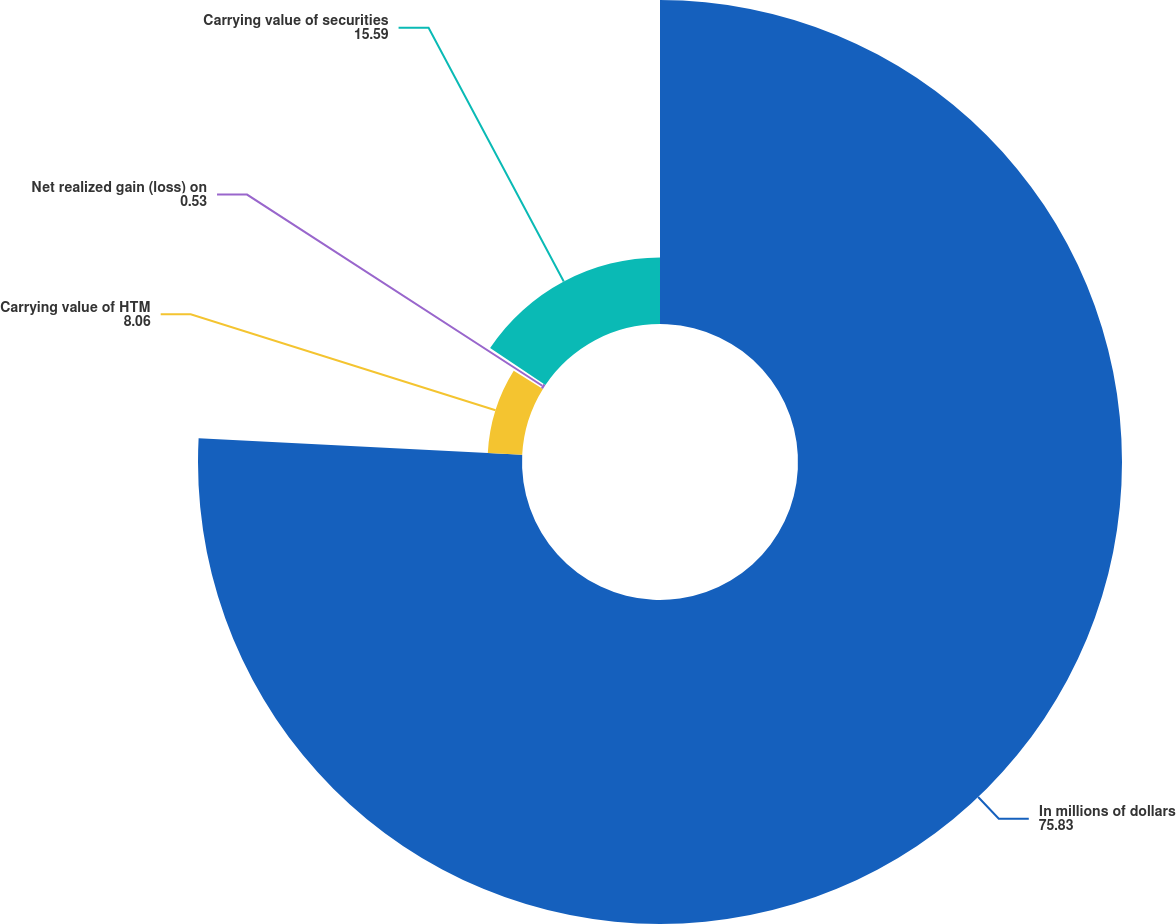<chart> <loc_0><loc_0><loc_500><loc_500><pie_chart><fcel>In millions of dollars<fcel>Carrying value of HTM<fcel>Net realized gain (loss) on<fcel>Carrying value of securities<nl><fcel>75.83%<fcel>8.06%<fcel>0.53%<fcel>15.59%<nl></chart> 